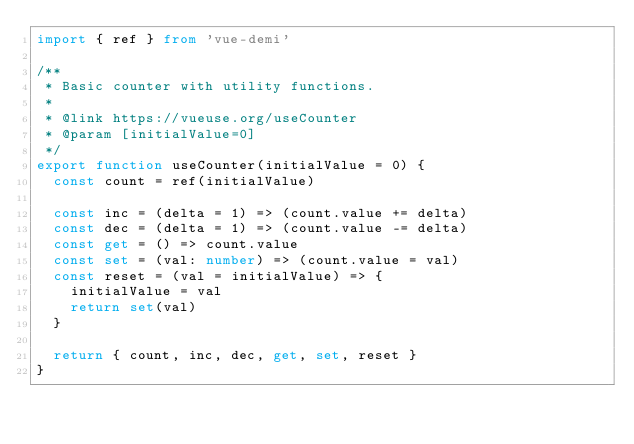Convert code to text. <code><loc_0><loc_0><loc_500><loc_500><_TypeScript_>import { ref } from 'vue-demi'

/**
 * Basic counter with utility functions.
 *
 * @link https://vueuse.org/useCounter
 * @param [initialValue=0]
 */
export function useCounter(initialValue = 0) {
  const count = ref(initialValue)

  const inc = (delta = 1) => (count.value += delta)
  const dec = (delta = 1) => (count.value -= delta)
  const get = () => count.value
  const set = (val: number) => (count.value = val)
  const reset = (val = initialValue) => {
    initialValue = val
    return set(val)
  }

  return { count, inc, dec, get, set, reset }
}
</code> 